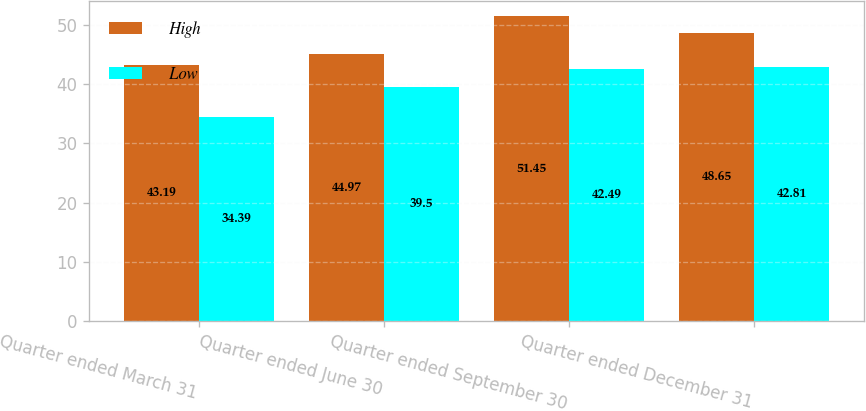Convert chart. <chart><loc_0><loc_0><loc_500><loc_500><stacked_bar_chart><ecel><fcel>Quarter ended March 31<fcel>Quarter ended June 30<fcel>Quarter ended September 30<fcel>Quarter ended December 31<nl><fcel>High<fcel>43.19<fcel>44.97<fcel>51.45<fcel>48.65<nl><fcel>Low<fcel>34.39<fcel>39.5<fcel>42.49<fcel>42.81<nl></chart> 